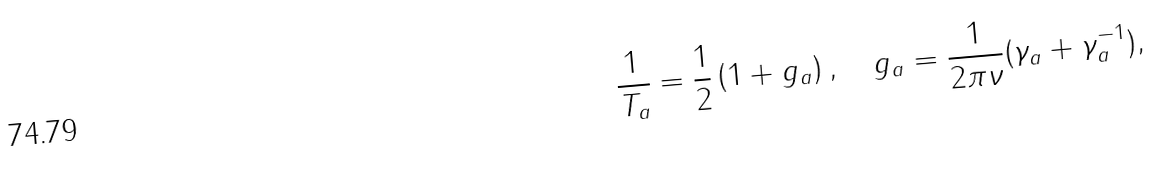Convert formula to latex. <formula><loc_0><loc_0><loc_500><loc_500>\frac { 1 } { T _ { a } } = \frac { 1 } { 2 } \left ( 1 + g _ { a } \right ) , \quad g _ { a } = \frac { 1 } { 2 \pi \nu } ( \gamma _ { a } + \gamma _ { a } ^ { - 1 } ) ,</formula> 